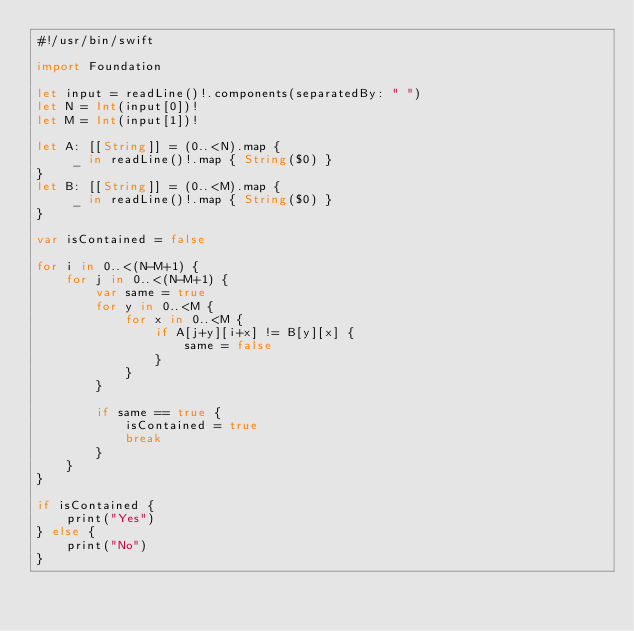<code> <loc_0><loc_0><loc_500><loc_500><_Swift_>#!/usr/bin/swift

import Foundation

let input = readLine()!.components(separatedBy: " ")
let N = Int(input[0])!
let M = Int(input[1])!

let A: [[String]] = (0..<N).map {
     _ in readLine()!.map { String($0) }
}
let B: [[String]] = (0..<M).map {
     _ in readLine()!.map { String($0) }
}

var isContained = false

for i in 0..<(N-M+1) {
    for j in 0..<(N-M+1) {
        var same = true
        for y in 0..<M {
            for x in 0..<M {
                if A[j+y][i+x] != B[y][x] {
                    same = false
                }
            }
        }

        if same == true {
            isContained = true
            break
        }
    }
}

if isContained {
    print("Yes")
} else {
    print("No")
}
</code> 